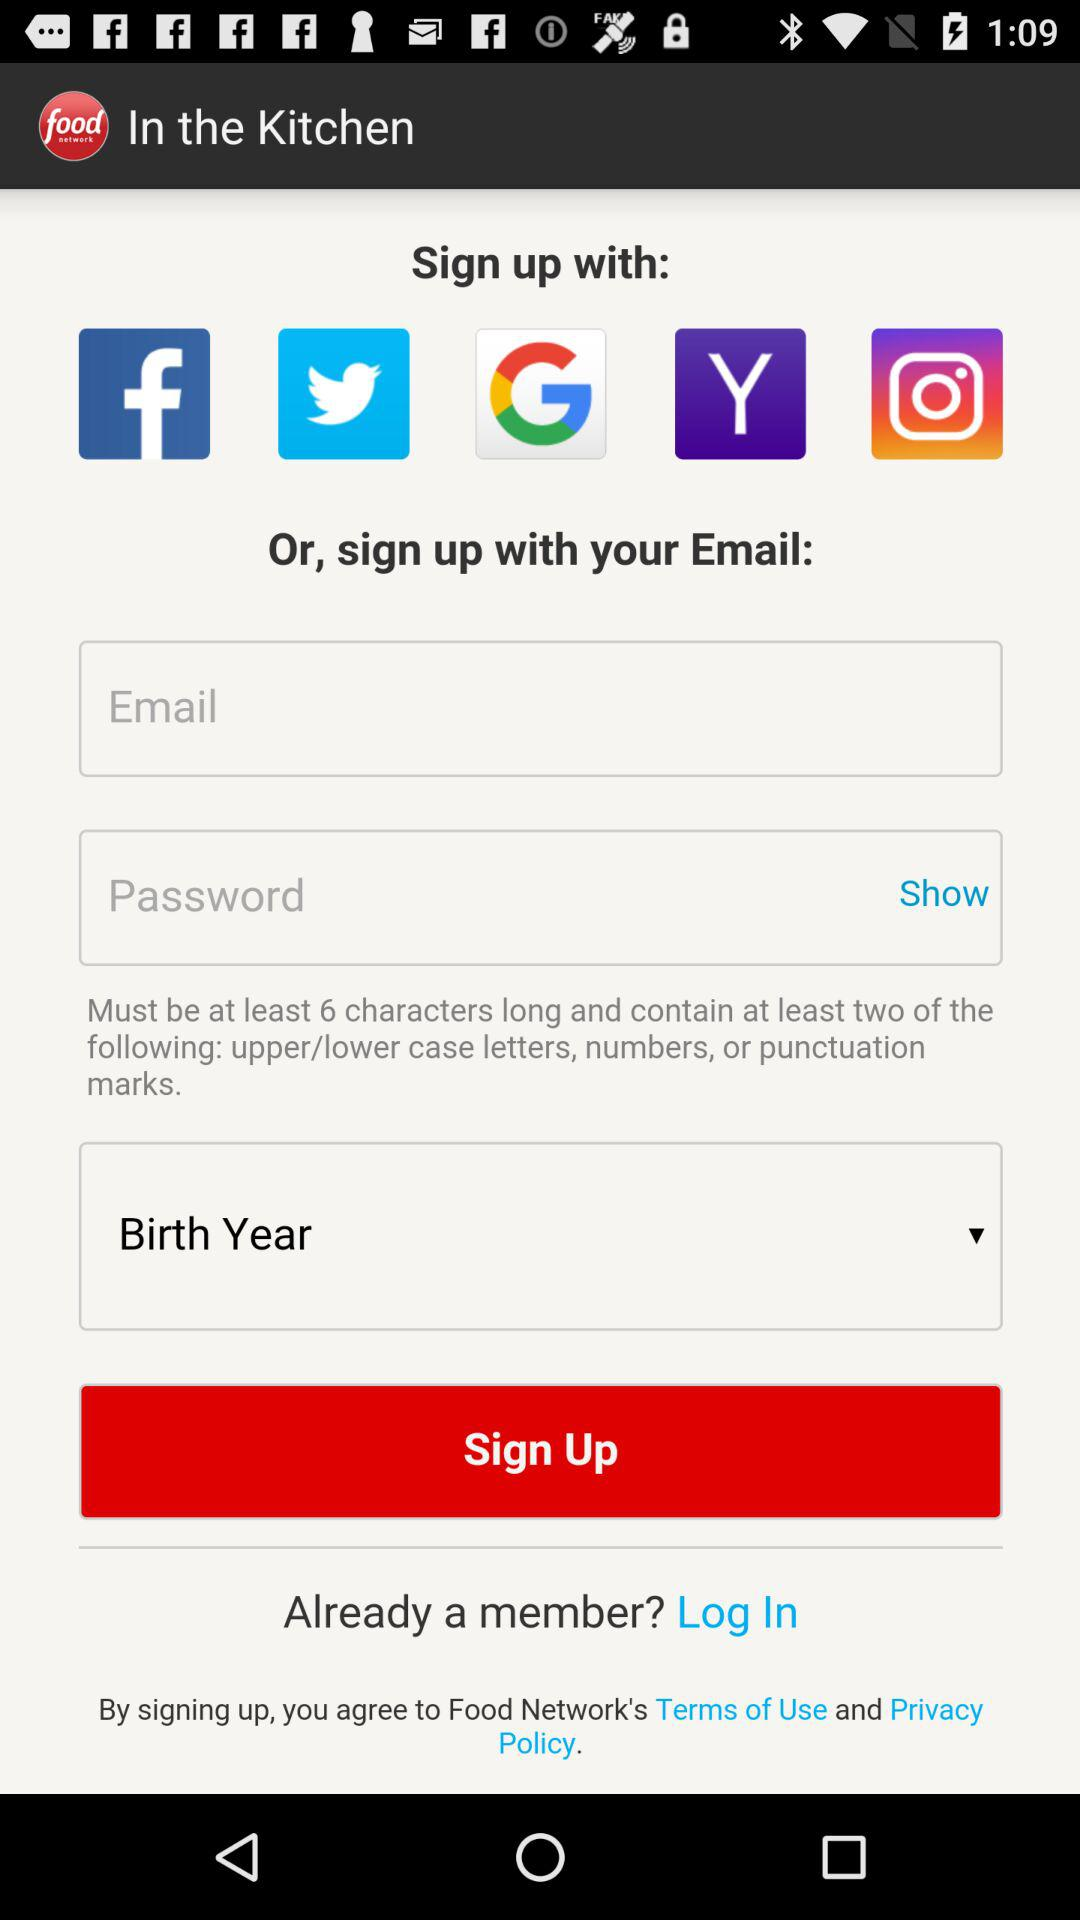What is the name of the application? The name of the application is "food network". 